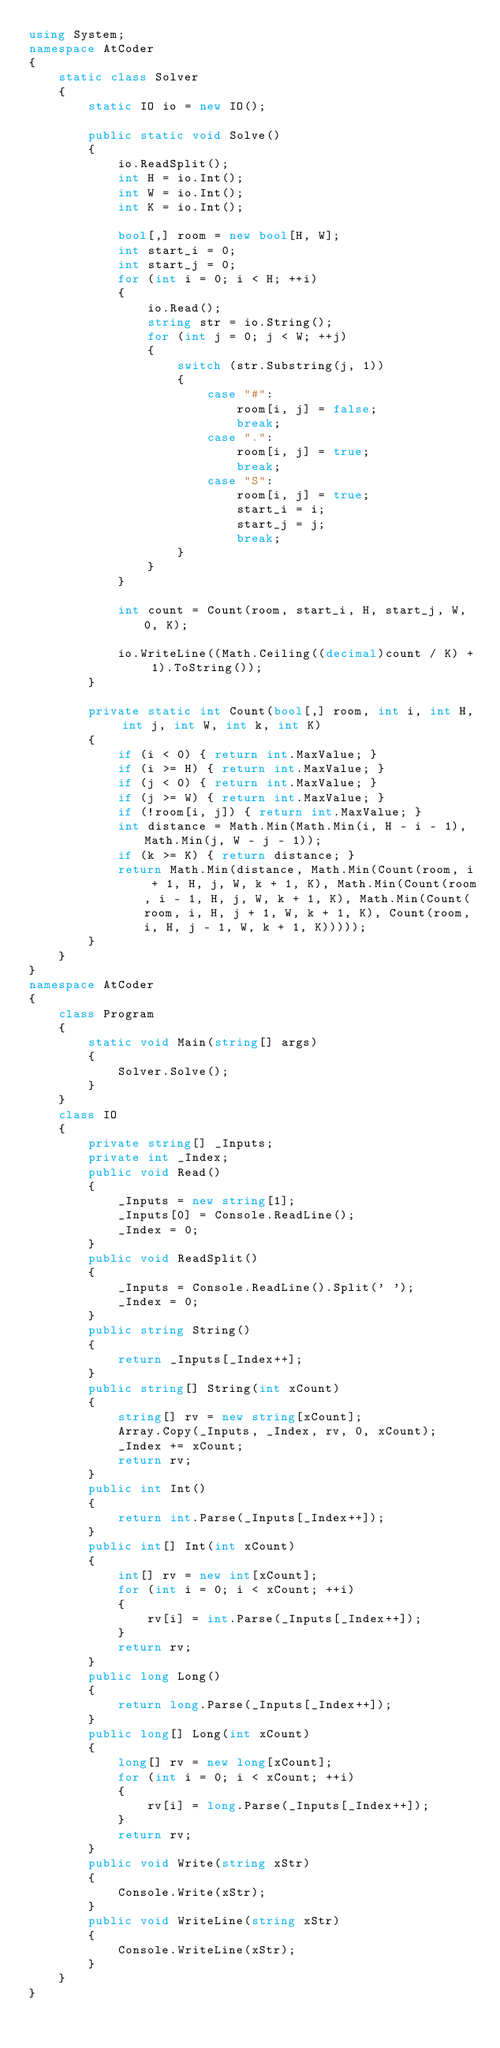<code> <loc_0><loc_0><loc_500><loc_500><_C#_>using System;
namespace AtCoder
{
    static class Solver
    {
        static IO io = new IO();

        public static void Solve()
        {
            io.ReadSplit();
            int H = io.Int();
            int W = io.Int();
            int K = io.Int();

            bool[,] room = new bool[H, W];
            int start_i = 0;
            int start_j = 0;
            for (int i = 0; i < H; ++i)
            {
                io.Read();
                string str = io.String();
                for (int j = 0; j < W; ++j)
                {
                    switch (str.Substring(j, 1))
                    {
                        case "#":
                            room[i, j] = false;
                            break;
                        case ".":
                            room[i, j] = true;
                            break;
                        case "S":
                            room[i, j] = true;
                            start_i = i;
                            start_j = j;
                            break;
                    }
                }
            }

            int count = Count(room, start_i, H, start_j, W, 0, K);

            io.WriteLine((Math.Ceiling((decimal)count / K) + 1).ToString());
        }

        private static int Count(bool[,] room, int i, int H, int j, int W, int k, int K)
        {
            if (i < 0) { return int.MaxValue; }
            if (i >= H) { return int.MaxValue; }
            if (j < 0) { return int.MaxValue; }
            if (j >= W) { return int.MaxValue; }
            if (!room[i, j]) { return int.MaxValue; }
            int distance = Math.Min(Math.Min(i, H - i - 1), Math.Min(j, W - j - 1));
            if (k >= K) { return distance; }
            return Math.Min(distance, Math.Min(Count(room, i + 1, H, j, W, k + 1, K), Math.Min(Count(room, i - 1, H, j, W, k + 1, K), Math.Min(Count(room, i, H, j + 1, W, k + 1, K), Count(room, i, H, j - 1, W, k + 1, K)))));
        }
    }
}
namespace AtCoder
{
    class Program
    {
        static void Main(string[] args)
        {
            Solver.Solve();
        }
    }
    class IO
    {
        private string[] _Inputs;
        private int _Index;
        public void Read()
        {
            _Inputs = new string[1];
            _Inputs[0] = Console.ReadLine();
            _Index = 0;
        }
        public void ReadSplit()
        {
            _Inputs = Console.ReadLine().Split(' ');
            _Index = 0;
        }
        public string String()
        {
            return _Inputs[_Index++];
        }
        public string[] String(int xCount)
        {
            string[] rv = new string[xCount];
            Array.Copy(_Inputs, _Index, rv, 0, xCount);
            _Index += xCount;
            return rv;
        }
        public int Int()
        {
            return int.Parse(_Inputs[_Index++]);
        }
        public int[] Int(int xCount)
        {
            int[] rv = new int[xCount];
            for (int i = 0; i < xCount; ++i)
            {
                rv[i] = int.Parse(_Inputs[_Index++]);
            }
            return rv;
        }
        public long Long()
        {
            return long.Parse(_Inputs[_Index++]);
        }
        public long[] Long(int xCount)
        {
            long[] rv = new long[xCount];
            for (int i = 0; i < xCount; ++i)
            {
                rv[i] = long.Parse(_Inputs[_Index++]);
            }
            return rv;
        }
        public void Write(string xStr)
        {
            Console.Write(xStr);
        }
        public void WriteLine(string xStr)
        {
            Console.WriteLine(xStr);
        }
    }
}</code> 